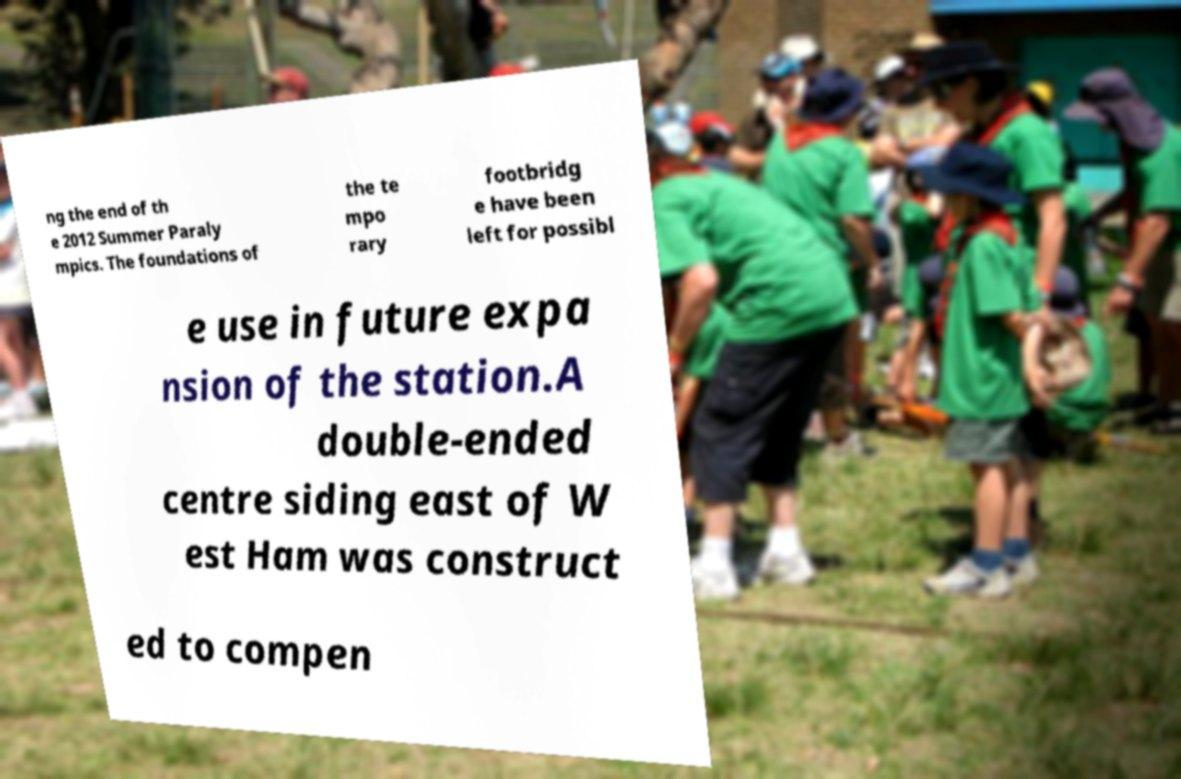For documentation purposes, I need the text within this image transcribed. Could you provide that? ng the end of th e 2012 Summer Paraly mpics. The foundations of the te mpo rary footbridg e have been left for possibl e use in future expa nsion of the station.A double-ended centre siding east of W est Ham was construct ed to compen 